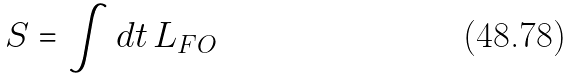<formula> <loc_0><loc_0><loc_500><loc_500>S = \int d t \, L _ { F O }</formula> 